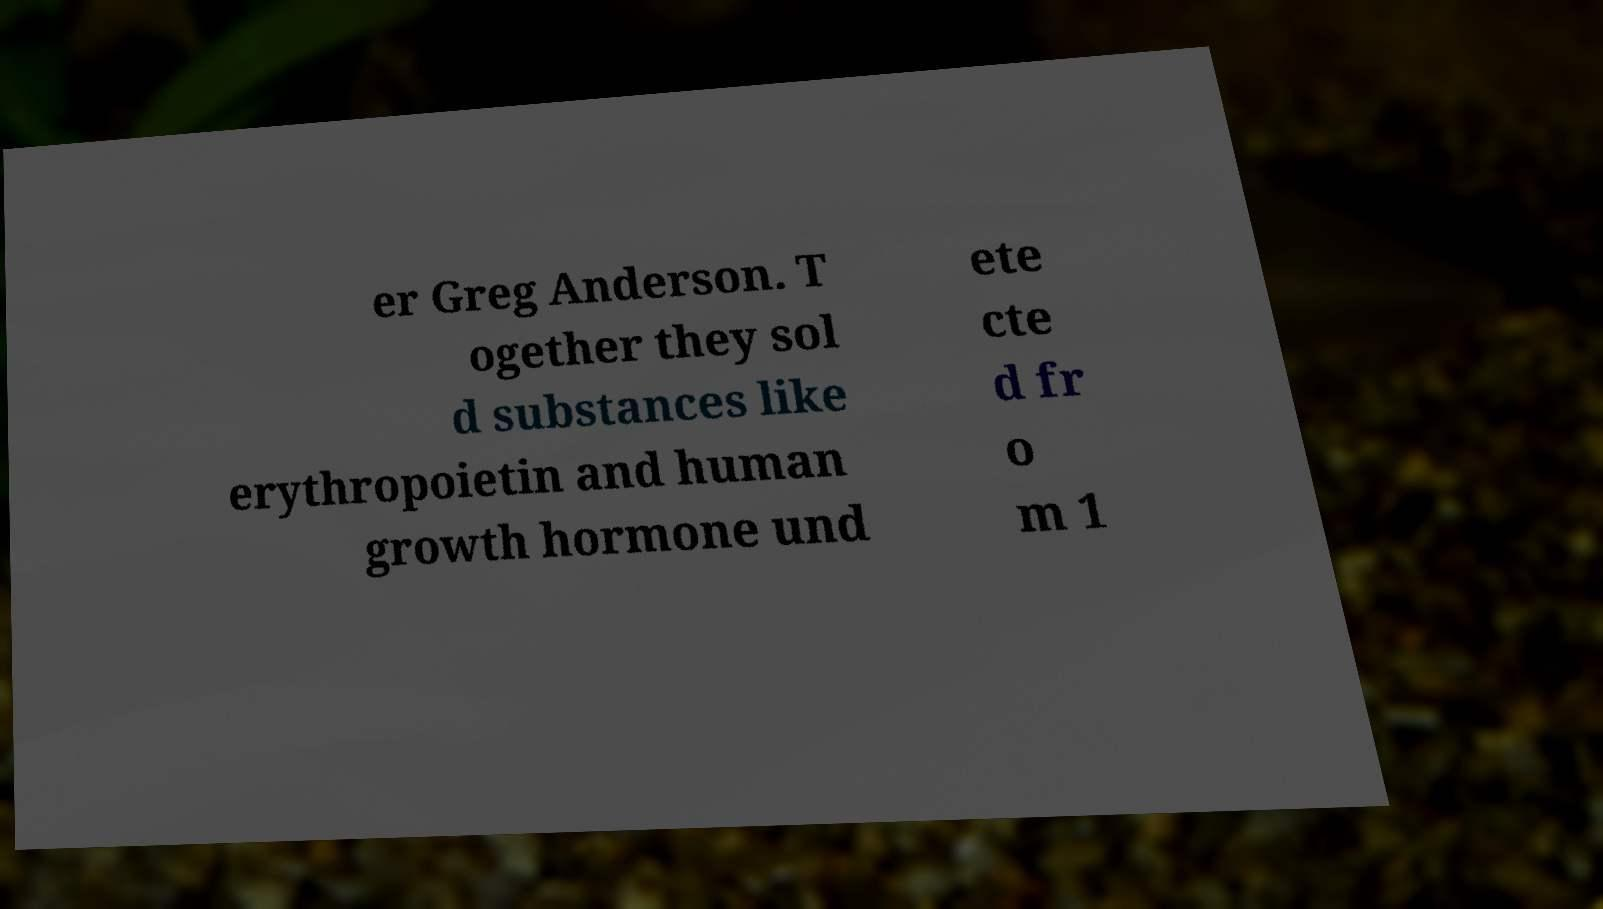Can you accurately transcribe the text from the provided image for me? er Greg Anderson. T ogether they sol d substances like erythropoietin and human growth hormone und ete cte d fr o m 1 